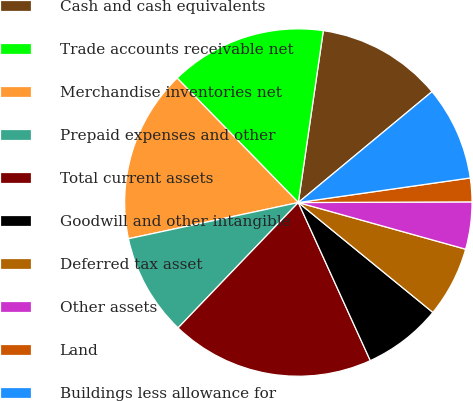<chart> <loc_0><loc_0><loc_500><loc_500><pie_chart><fcel>Cash and cash equivalents<fcel>Trade accounts receivable net<fcel>Merchandise inventories net<fcel>Prepaid expenses and other<fcel>Total current assets<fcel>Goodwill and other intangible<fcel>Deferred tax asset<fcel>Other assets<fcel>Land<fcel>Buildings less allowance for<nl><fcel>11.68%<fcel>14.59%<fcel>16.05%<fcel>9.49%<fcel>18.97%<fcel>7.3%<fcel>6.57%<fcel>4.39%<fcel>2.2%<fcel>8.76%<nl></chart> 